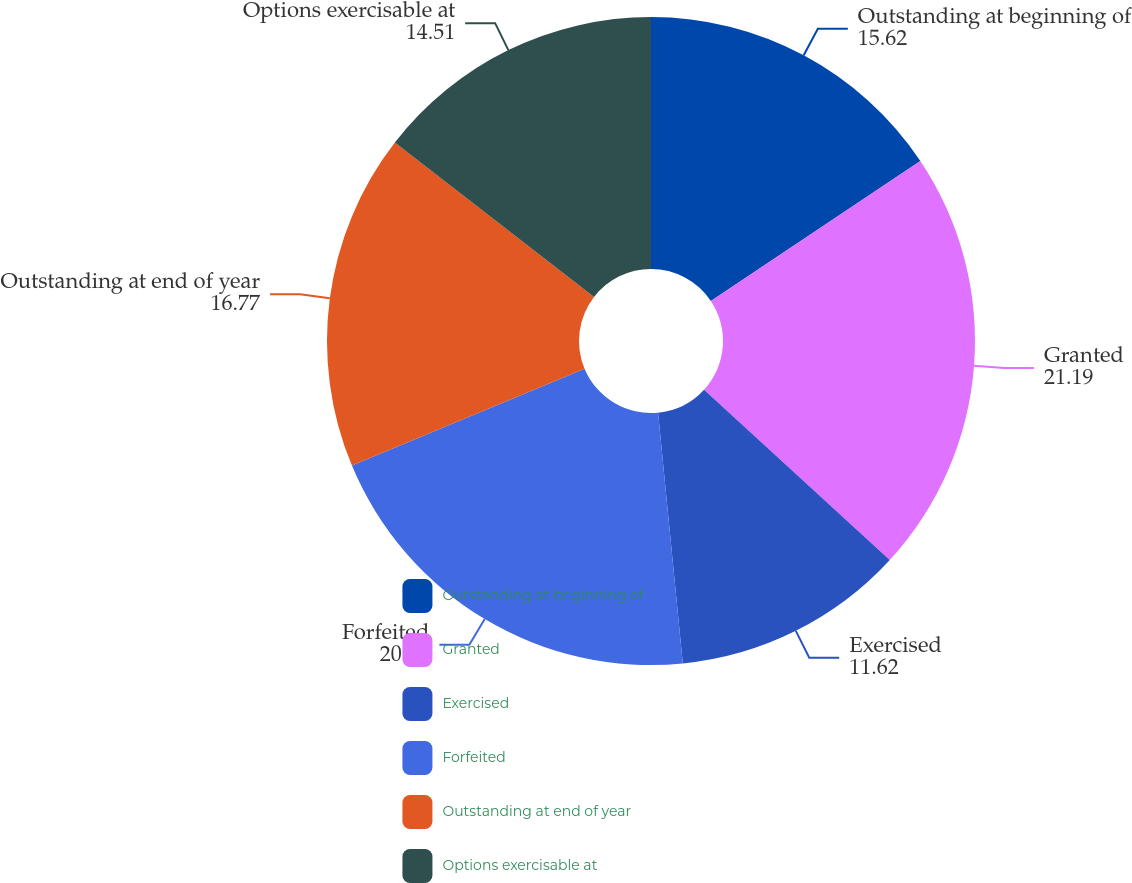Convert chart. <chart><loc_0><loc_0><loc_500><loc_500><pie_chart><fcel>Outstanding at beginning of<fcel>Granted<fcel>Exercised<fcel>Forfeited<fcel>Outstanding at end of year<fcel>Options exercisable at<nl><fcel>15.62%<fcel>21.19%<fcel>11.62%<fcel>20.28%<fcel>16.77%<fcel>14.51%<nl></chart> 